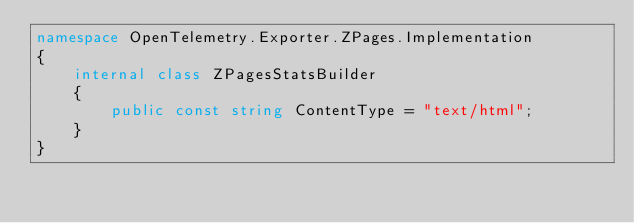<code> <loc_0><loc_0><loc_500><loc_500><_C#_>namespace OpenTelemetry.Exporter.ZPages.Implementation
{
    internal class ZPagesStatsBuilder
    {
        public const string ContentType = "text/html";
    }
}
</code> 